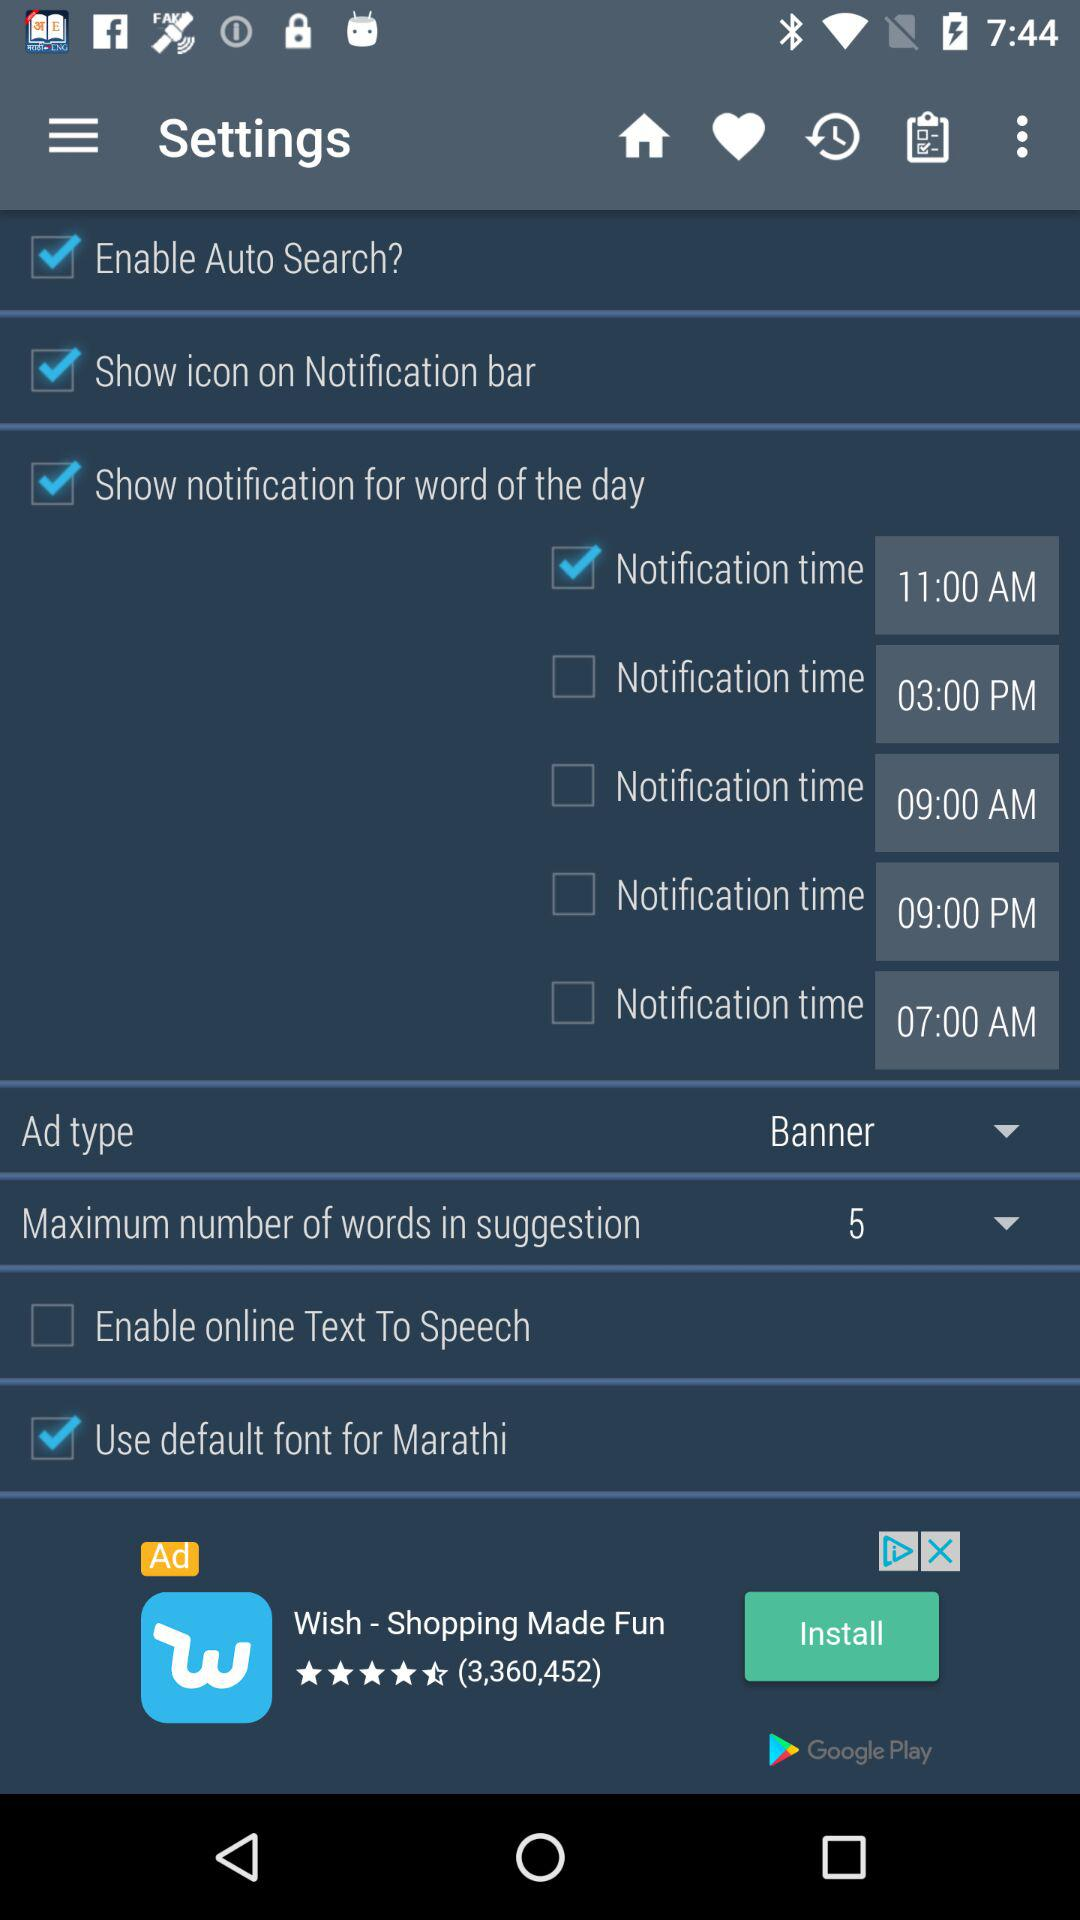How many notification times are there?
Answer the question using a single word or phrase. 5 